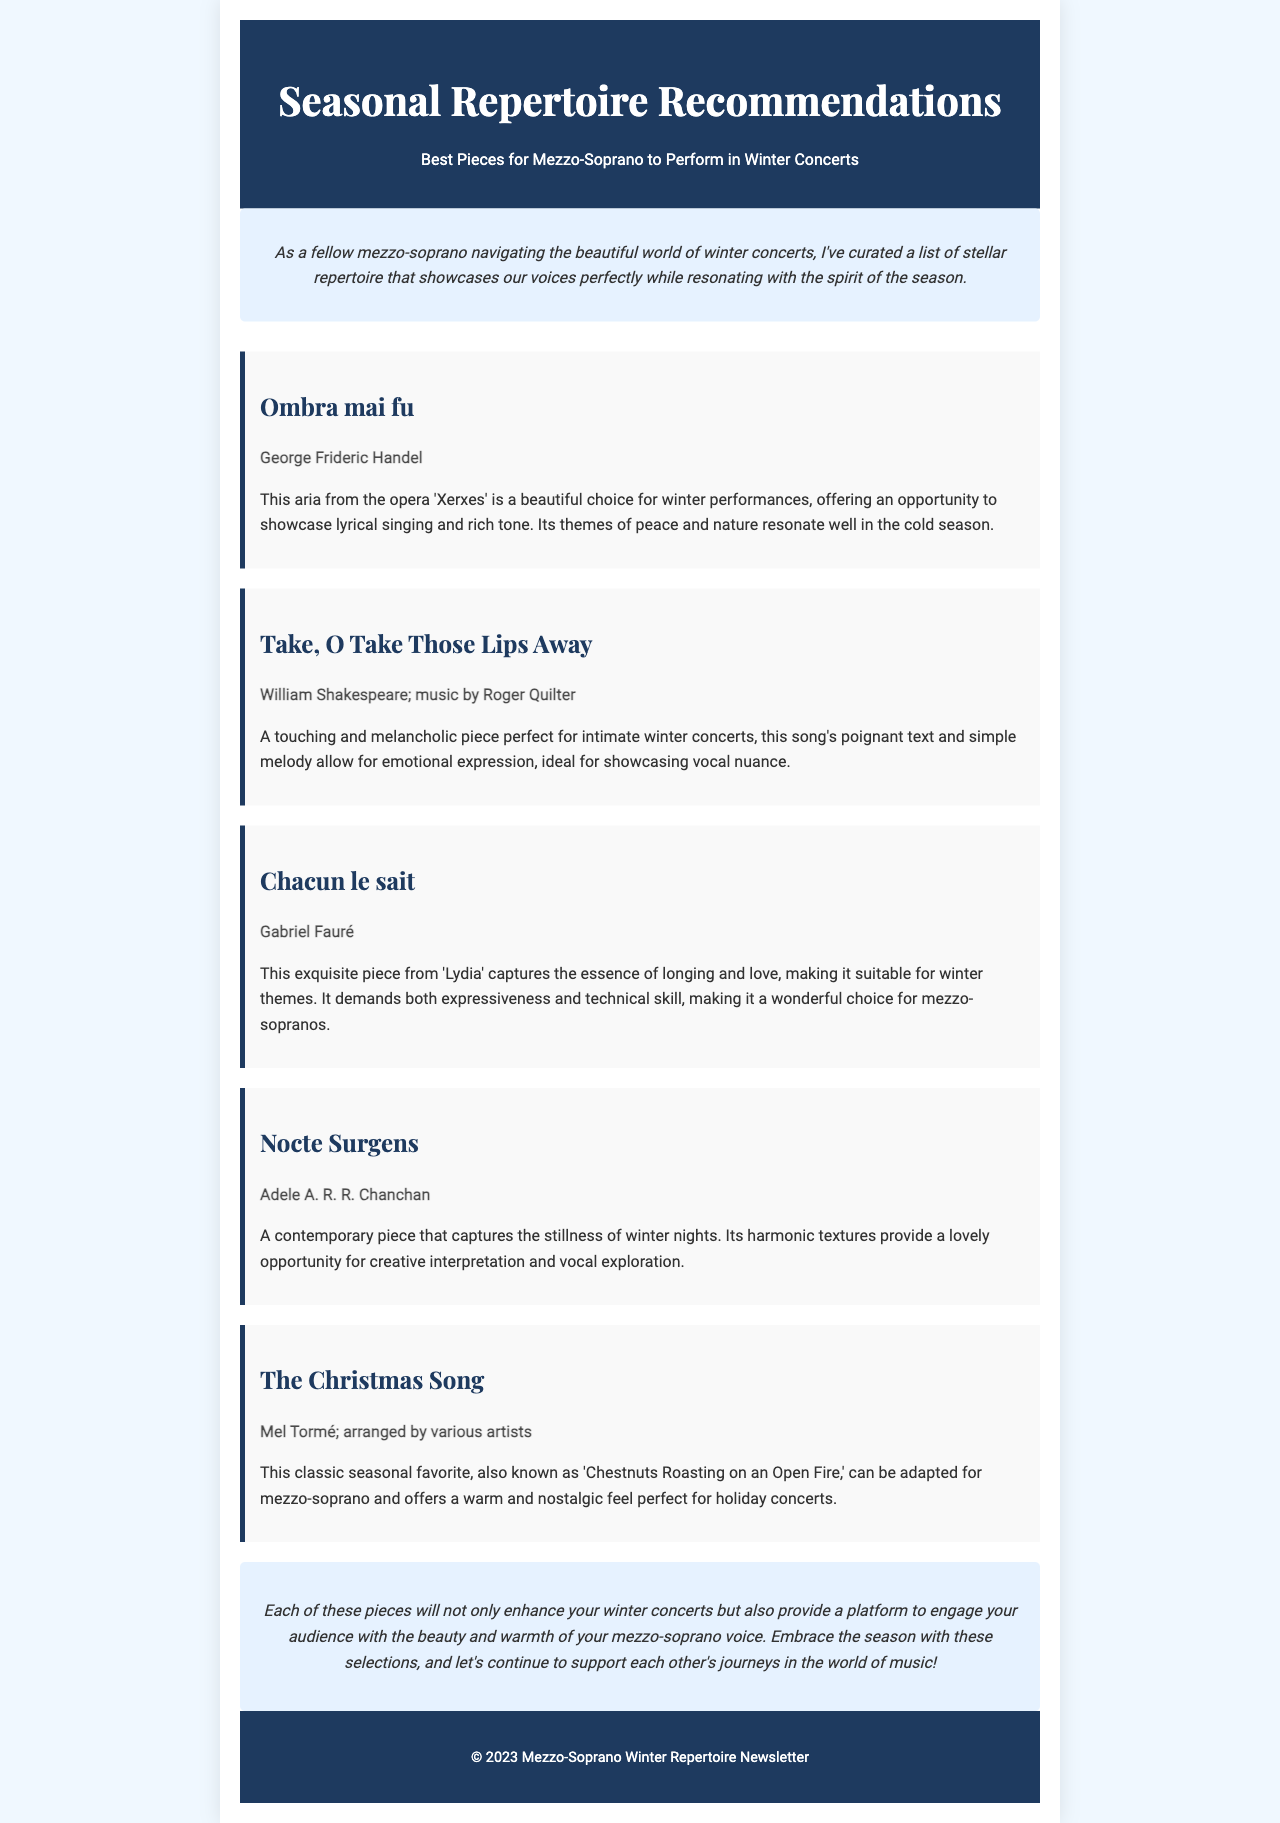What is the title of the newsletter? The title of the newsletter is presented in the header section of the document.
Answer: Seasonal Repertoire Recommendations Who is the composer of "Ombra mai fu"? The composer is listed below the title of the piece in the recommendation section.
Answer: George Frideric Handel What type of piece is "Take, O Take Those Lips Away"? The document describes this piece as a song in the recommendation section.
Answer: Song Which piece captures the stillness of winter nights? The recommendation specifically states which piece captures this essence.
Answer: Nocte Surgens How many recommendations are included in the document? The document lists the number of pieces recommended in the recommendations section.
Answer: Five Which composer is associated with "Chacun le sait"? The composer is mentioned under the title in the respective recommendation.
Answer: Gabriel Fauré What is the common theme of the recommended pieces? The pieces are described in a way that indicates their thematic connection throughout the document.
Answer: Winter What is the emotional tone of "Take, O Take Those Lips Away"? The document provides a qualitative description of the piece's emotional impact.
Answer: Touching and melancholic 